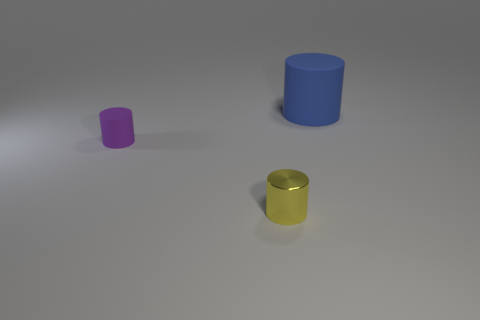There is a rubber object to the left of the big rubber cylinder; how many blue objects are left of it?
Give a very brief answer. 0. Do the rubber thing that is on the left side of the small metal cylinder and the rubber object that is on the right side of the small yellow object have the same shape?
Ensure brevity in your answer.  Yes. There is a yellow shiny thing; how many tiny cylinders are behind it?
Your answer should be compact. 1. Is the object in front of the tiny matte object made of the same material as the tiny purple object?
Offer a terse response. No. The other tiny object that is the same shape as the tiny purple rubber thing is what color?
Offer a terse response. Yellow. What shape is the large matte object?
Provide a short and direct response. Cylinder. What number of objects are yellow cylinders or tiny purple things?
Your response must be concise. 2. There is a rubber cylinder that is to the left of the blue rubber cylinder; is its color the same as the object behind the tiny rubber cylinder?
Keep it short and to the point. No. How many other objects are there of the same shape as the small metal thing?
Keep it short and to the point. 2. Are there any small blue spheres?
Make the answer very short. No. 